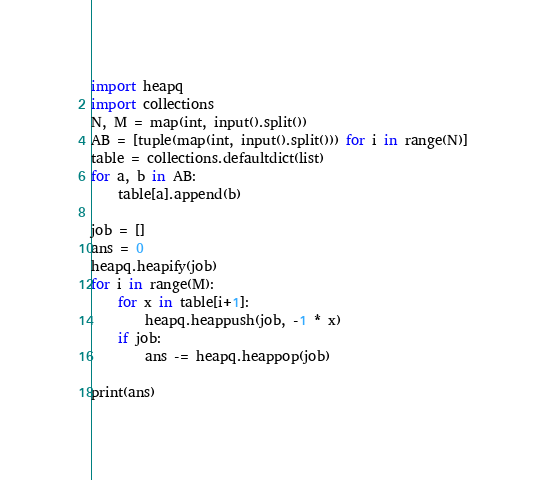Convert code to text. <code><loc_0><loc_0><loc_500><loc_500><_Python_>import heapq
import collections
N, M = map(int, input().split())
AB = [tuple(map(int, input().split())) for i in range(N)]
table = collections.defaultdict(list)
for a, b in AB:
    table[a].append(b)

job = []
ans = 0
heapq.heapify(job)
for i in range(M):
    for x in table[i+1]:
        heapq.heappush(job, -1 * x)
    if job:
        ans -= heapq.heappop(job)

print(ans)
</code> 